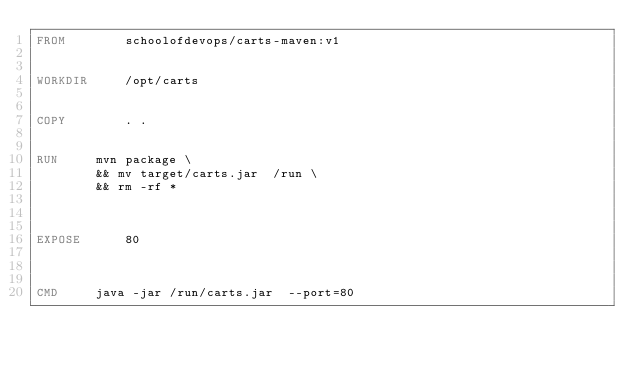Convert code to text. <code><loc_0><loc_0><loc_500><loc_500><_Dockerfile_>FROM		schoolofdevops/carts-maven:v1


WORKDIR		/opt/carts


COPY		. .


RUN		mvn package \
		&& mv target/carts.jar  /run \
		&& rm -rf *



EXPOSE		80



CMD		java -jar /run/carts.jar  --port=80
</code> 